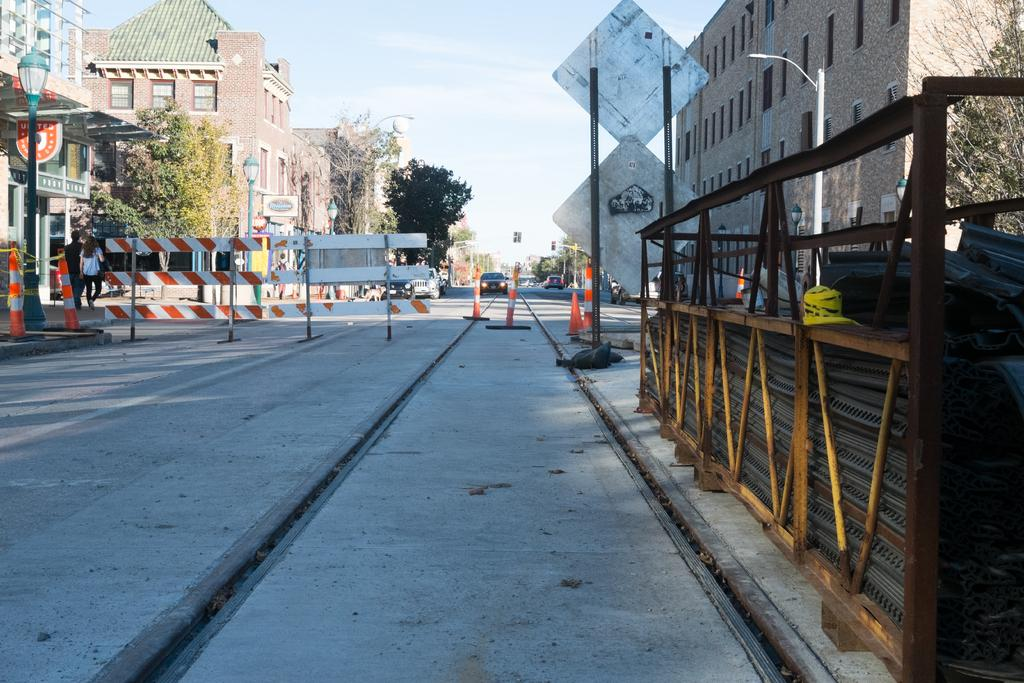What type of structures can be seen in the image? There are barriers, a building, and sign boards visible in the image. What natural elements are present in the image? There are trees in the image. What type of vehicles can be seen in the image? There are cars in the image. What other objects can be seen in the image? There are poles and a wooden object visible on the right side of the image. Where is the sink located in the image? There is no sink present in the image. What type of writing instrument is being used by the tree in the image? Trees do not use writing instruments, and there is no person or animal using a quill in the image. 